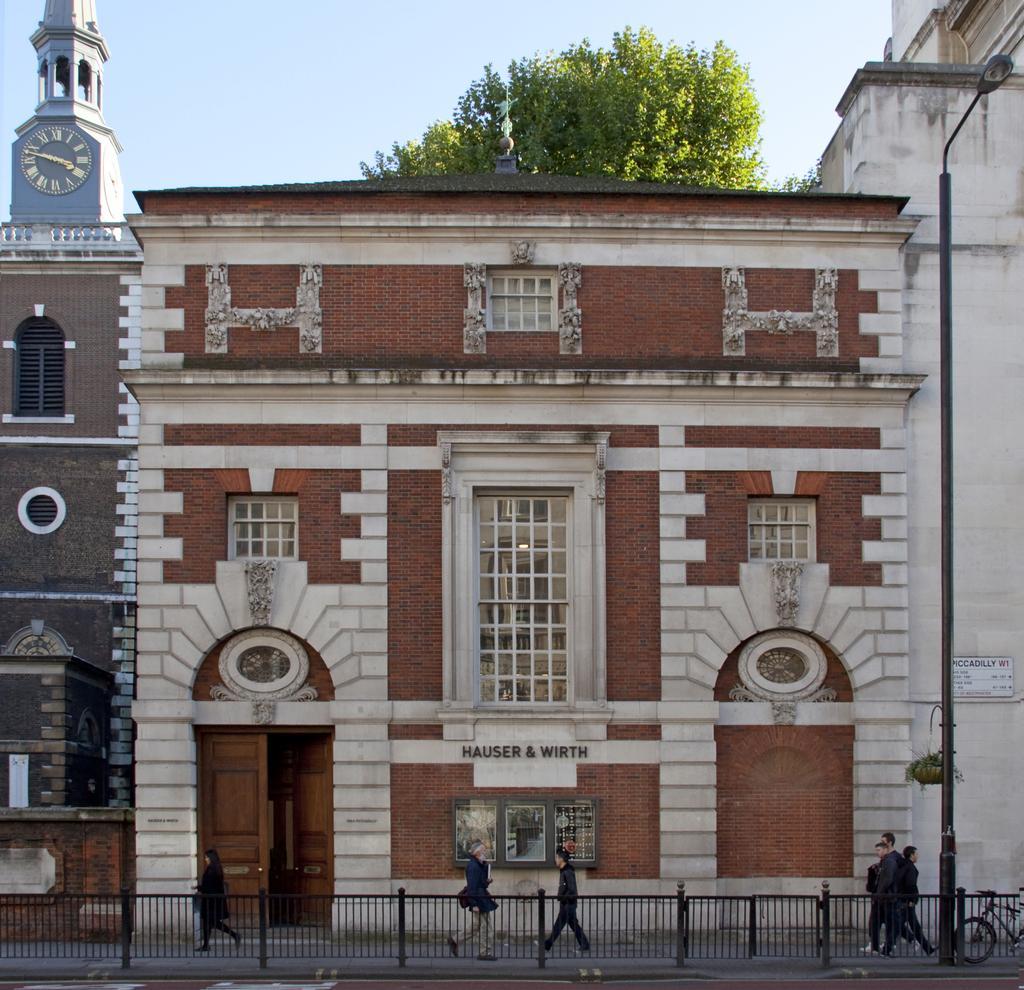Could you give a brief overview of what you see in this image? In this picture there are buildings in the image and there is a clock tower at the top left side of the image and there is a tree at the top side of the image, there are people and a boundary at the bottom side of the image. 